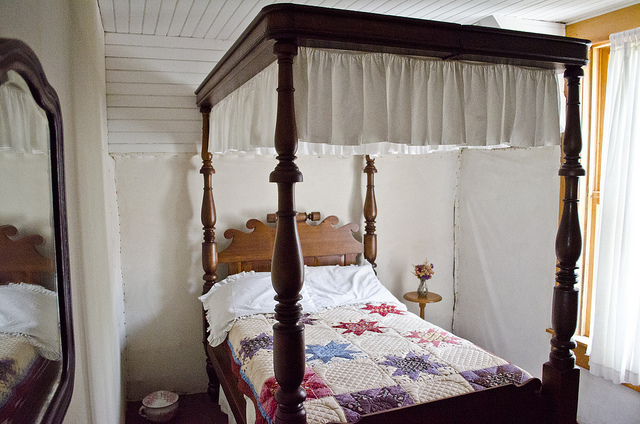<image>What type of patterns do the pillows have? I don't know the exact pattern of the pillows from the given responses. However, they appear to be plain or solid white. What type of patterns do the pillows have? I don't know what type of patterns the pillows have. It can be seen as 'none', 'plain white', 'solid', or 'normal'. 